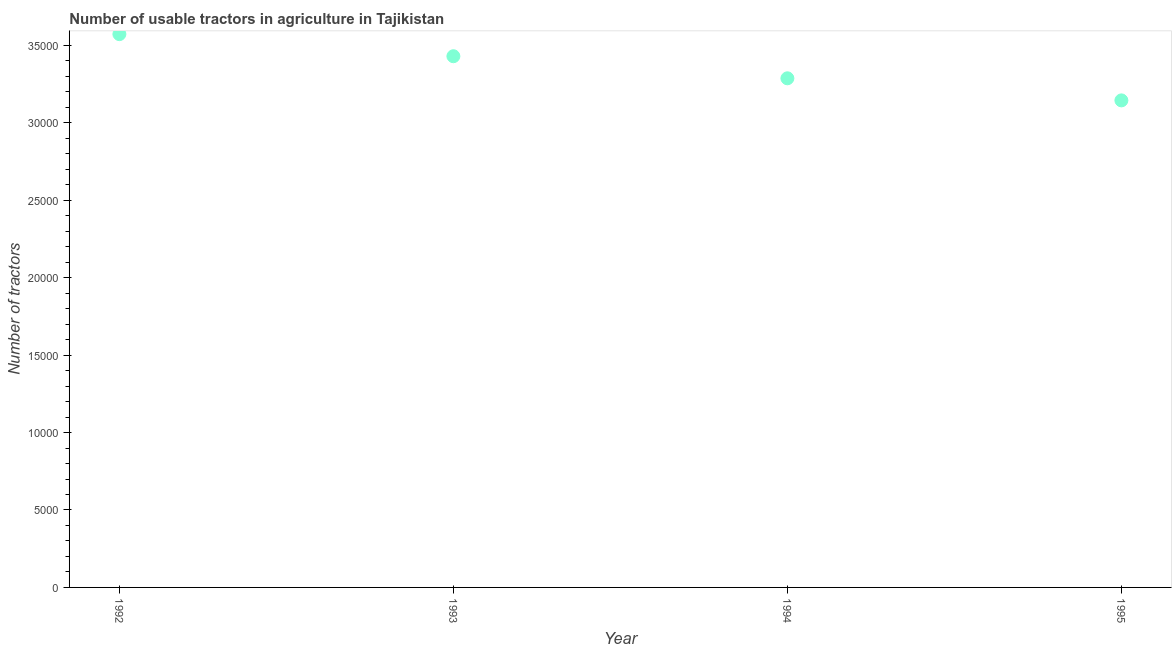What is the number of tractors in 1995?
Your answer should be very brief. 3.14e+04. Across all years, what is the maximum number of tractors?
Make the answer very short. 3.57e+04. Across all years, what is the minimum number of tractors?
Provide a short and direct response. 3.14e+04. What is the sum of the number of tractors?
Offer a terse response. 1.34e+05. What is the difference between the number of tractors in 1992 and 1995?
Provide a succinct answer. 4278. What is the average number of tractors per year?
Your answer should be compact. 3.36e+04. What is the median number of tractors?
Provide a succinct answer. 3.36e+04. In how many years, is the number of tractors greater than 12000 ?
Provide a short and direct response. 4. What is the ratio of the number of tractors in 1993 to that in 1995?
Offer a very short reply. 1.09. Is the number of tractors in 1992 less than that in 1994?
Make the answer very short. No. What is the difference between the highest and the second highest number of tractors?
Give a very brief answer. 1426. Is the sum of the number of tractors in 1992 and 1994 greater than the maximum number of tractors across all years?
Provide a succinct answer. Yes. What is the difference between the highest and the lowest number of tractors?
Your answer should be compact. 4278. Does the number of tractors monotonically increase over the years?
Offer a terse response. No. How many dotlines are there?
Keep it short and to the point. 1. Are the values on the major ticks of Y-axis written in scientific E-notation?
Your response must be concise. No. Does the graph contain any zero values?
Provide a short and direct response. No. Does the graph contain grids?
Your response must be concise. No. What is the title of the graph?
Give a very brief answer. Number of usable tractors in agriculture in Tajikistan. What is the label or title of the X-axis?
Give a very brief answer. Year. What is the label or title of the Y-axis?
Make the answer very short. Number of tractors. What is the Number of tractors in 1992?
Your answer should be very brief. 3.57e+04. What is the Number of tractors in 1993?
Your answer should be compact. 3.43e+04. What is the Number of tractors in 1994?
Offer a very short reply. 3.29e+04. What is the Number of tractors in 1995?
Offer a very short reply. 3.14e+04. What is the difference between the Number of tractors in 1992 and 1993?
Your answer should be very brief. 1426. What is the difference between the Number of tractors in 1992 and 1994?
Keep it short and to the point. 2852. What is the difference between the Number of tractors in 1992 and 1995?
Your response must be concise. 4278. What is the difference between the Number of tractors in 1993 and 1994?
Offer a terse response. 1426. What is the difference between the Number of tractors in 1993 and 1995?
Offer a terse response. 2852. What is the difference between the Number of tractors in 1994 and 1995?
Offer a very short reply. 1426. What is the ratio of the Number of tractors in 1992 to that in 1993?
Make the answer very short. 1.04. What is the ratio of the Number of tractors in 1992 to that in 1994?
Your response must be concise. 1.09. What is the ratio of the Number of tractors in 1992 to that in 1995?
Your answer should be compact. 1.14. What is the ratio of the Number of tractors in 1993 to that in 1994?
Your answer should be compact. 1.04. What is the ratio of the Number of tractors in 1993 to that in 1995?
Provide a short and direct response. 1.09. What is the ratio of the Number of tractors in 1994 to that in 1995?
Your answer should be compact. 1.04. 